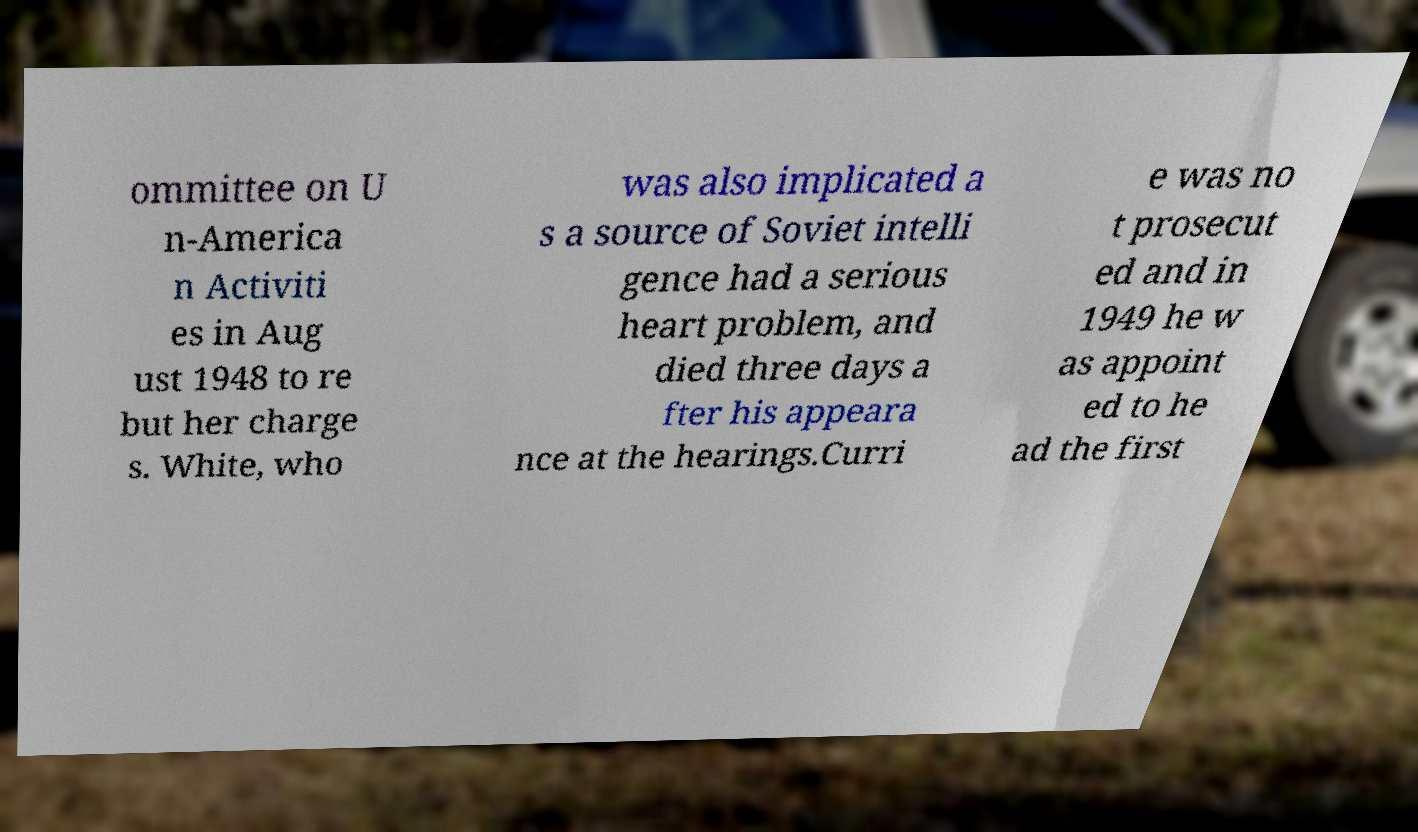There's text embedded in this image that I need extracted. Can you transcribe it verbatim? ommittee on U n-America n Activiti es in Aug ust 1948 to re but her charge s. White, who was also implicated a s a source of Soviet intelli gence had a serious heart problem, and died three days a fter his appeara nce at the hearings.Curri e was no t prosecut ed and in 1949 he w as appoint ed to he ad the first 